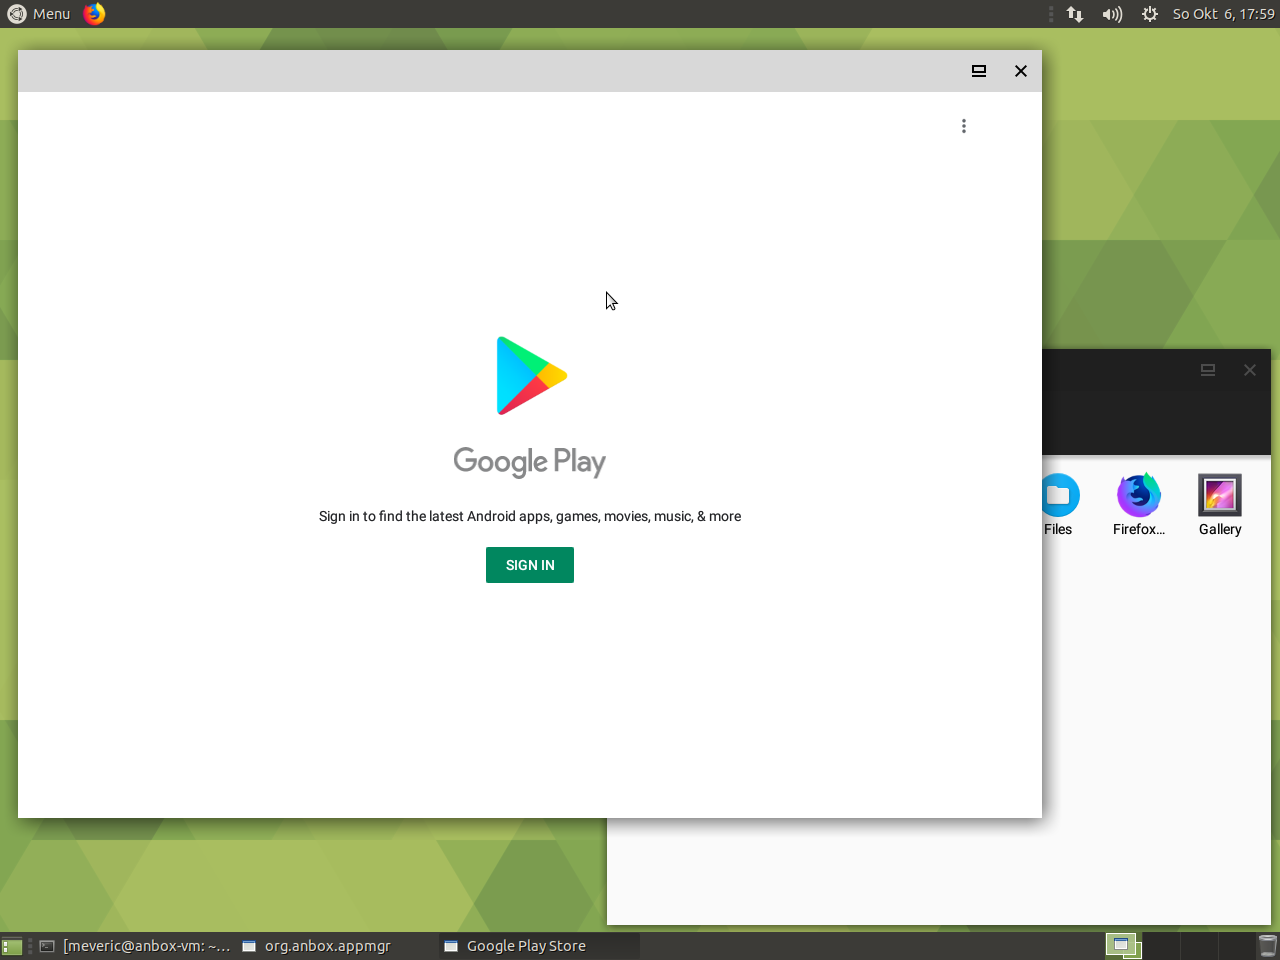What operating system might this device be using? Based on the image, it seems that the device is using an Android operating system, more specifically an emulator or a compatibility layer that allows Android apps to run on a different OS, possibly Linux. This is evidenced by the Google Play Store app being displayed on what looks like a desktop environment, an unusual sighting unless specialized software is used. 